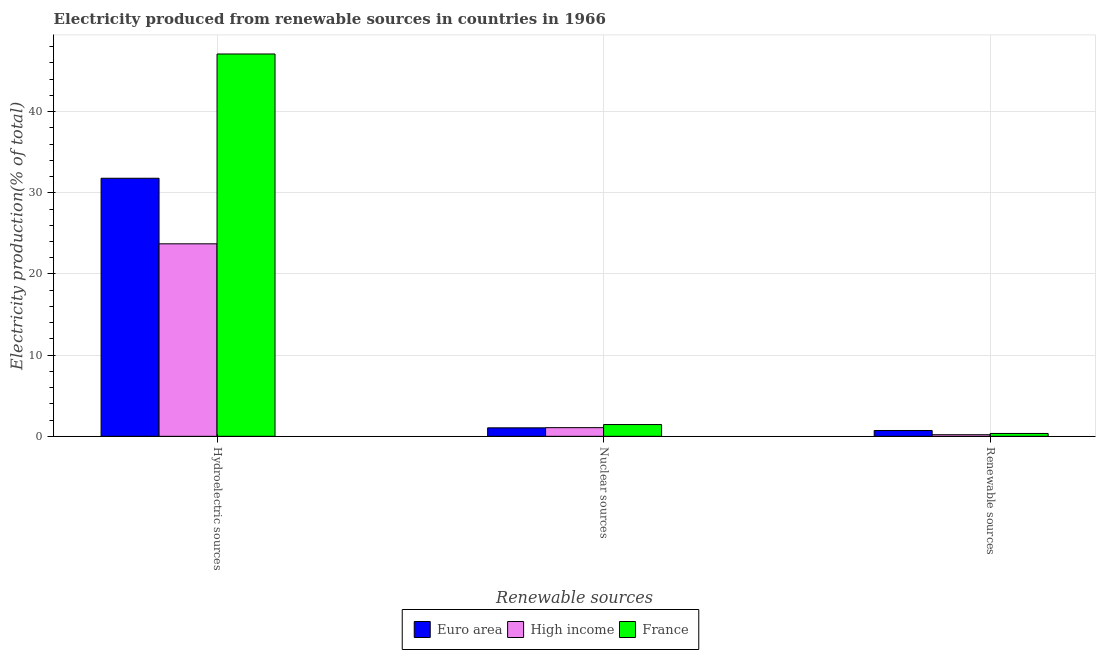How many different coloured bars are there?
Give a very brief answer. 3. How many groups of bars are there?
Your answer should be very brief. 3. Are the number of bars per tick equal to the number of legend labels?
Ensure brevity in your answer.  Yes. Are the number of bars on each tick of the X-axis equal?
Your response must be concise. Yes. How many bars are there on the 2nd tick from the left?
Provide a succinct answer. 3. How many bars are there on the 1st tick from the right?
Your response must be concise. 3. What is the label of the 2nd group of bars from the left?
Your answer should be compact. Nuclear sources. What is the percentage of electricity produced by nuclear sources in High income?
Give a very brief answer. 1.07. Across all countries, what is the maximum percentage of electricity produced by renewable sources?
Your response must be concise. 0.72. Across all countries, what is the minimum percentage of electricity produced by hydroelectric sources?
Provide a succinct answer. 23.72. In which country was the percentage of electricity produced by nuclear sources minimum?
Keep it short and to the point. Euro area. What is the total percentage of electricity produced by hydroelectric sources in the graph?
Your answer should be very brief. 102.61. What is the difference between the percentage of electricity produced by renewable sources in France and that in Euro area?
Your response must be concise. -0.37. What is the difference between the percentage of electricity produced by nuclear sources in France and the percentage of electricity produced by renewable sources in High income?
Provide a short and direct response. 1.25. What is the average percentage of electricity produced by nuclear sources per country?
Offer a terse response. 1.19. What is the difference between the percentage of electricity produced by hydroelectric sources and percentage of electricity produced by renewable sources in High income?
Provide a short and direct response. 23.52. What is the ratio of the percentage of electricity produced by hydroelectric sources in High income to that in Euro area?
Give a very brief answer. 0.75. What is the difference between the highest and the second highest percentage of electricity produced by nuclear sources?
Give a very brief answer. 0.38. What is the difference between the highest and the lowest percentage of electricity produced by nuclear sources?
Provide a short and direct response. 0.4. What does the 3rd bar from the left in Renewable sources represents?
Offer a very short reply. France. How many bars are there?
Ensure brevity in your answer.  9. Are all the bars in the graph horizontal?
Offer a very short reply. No. How many countries are there in the graph?
Your answer should be very brief. 3. Where does the legend appear in the graph?
Ensure brevity in your answer.  Bottom center. What is the title of the graph?
Offer a very short reply. Electricity produced from renewable sources in countries in 1966. Does "Faeroe Islands" appear as one of the legend labels in the graph?
Ensure brevity in your answer.  No. What is the label or title of the X-axis?
Your response must be concise. Renewable sources. What is the label or title of the Y-axis?
Your response must be concise. Electricity production(% of total). What is the Electricity production(% of total) of Euro area in Hydroelectric sources?
Ensure brevity in your answer.  31.79. What is the Electricity production(% of total) in High income in Hydroelectric sources?
Your answer should be compact. 23.72. What is the Electricity production(% of total) in France in Hydroelectric sources?
Your response must be concise. 47.1. What is the Electricity production(% of total) in Euro area in Nuclear sources?
Provide a short and direct response. 1.04. What is the Electricity production(% of total) in High income in Nuclear sources?
Give a very brief answer. 1.07. What is the Electricity production(% of total) of France in Nuclear sources?
Provide a short and direct response. 1.45. What is the Electricity production(% of total) in Euro area in Renewable sources?
Ensure brevity in your answer.  0.72. What is the Electricity production(% of total) of High income in Renewable sources?
Your answer should be very brief. 0.2. What is the Electricity production(% of total) in France in Renewable sources?
Ensure brevity in your answer.  0.35. Across all Renewable sources, what is the maximum Electricity production(% of total) of Euro area?
Offer a terse response. 31.79. Across all Renewable sources, what is the maximum Electricity production(% of total) in High income?
Offer a very short reply. 23.72. Across all Renewable sources, what is the maximum Electricity production(% of total) of France?
Offer a very short reply. 47.1. Across all Renewable sources, what is the minimum Electricity production(% of total) in Euro area?
Give a very brief answer. 0.72. Across all Renewable sources, what is the minimum Electricity production(% of total) of High income?
Offer a terse response. 0.2. Across all Renewable sources, what is the minimum Electricity production(% of total) of France?
Your answer should be very brief. 0.35. What is the total Electricity production(% of total) of Euro area in the graph?
Offer a very short reply. 33.56. What is the total Electricity production(% of total) of High income in the graph?
Provide a succinct answer. 24.98. What is the total Electricity production(% of total) of France in the graph?
Keep it short and to the point. 48.9. What is the difference between the Electricity production(% of total) in Euro area in Hydroelectric sources and that in Nuclear sources?
Offer a very short reply. 30.75. What is the difference between the Electricity production(% of total) of High income in Hydroelectric sources and that in Nuclear sources?
Offer a terse response. 22.65. What is the difference between the Electricity production(% of total) in France in Hydroelectric sources and that in Nuclear sources?
Provide a short and direct response. 45.65. What is the difference between the Electricity production(% of total) in Euro area in Hydroelectric sources and that in Renewable sources?
Your answer should be compact. 31.08. What is the difference between the Electricity production(% of total) in High income in Hydroelectric sources and that in Renewable sources?
Offer a very short reply. 23.52. What is the difference between the Electricity production(% of total) in France in Hydroelectric sources and that in Renewable sources?
Offer a very short reply. 46.75. What is the difference between the Electricity production(% of total) of Euro area in Nuclear sources and that in Renewable sources?
Offer a very short reply. 0.33. What is the difference between the Electricity production(% of total) in High income in Nuclear sources and that in Renewable sources?
Your answer should be compact. 0.87. What is the difference between the Electricity production(% of total) in France in Nuclear sources and that in Renewable sources?
Provide a short and direct response. 1.1. What is the difference between the Electricity production(% of total) in Euro area in Hydroelectric sources and the Electricity production(% of total) in High income in Nuclear sources?
Your answer should be very brief. 30.73. What is the difference between the Electricity production(% of total) in Euro area in Hydroelectric sources and the Electricity production(% of total) in France in Nuclear sources?
Your response must be concise. 30.34. What is the difference between the Electricity production(% of total) of High income in Hydroelectric sources and the Electricity production(% of total) of France in Nuclear sources?
Your answer should be very brief. 22.27. What is the difference between the Electricity production(% of total) of Euro area in Hydroelectric sources and the Electricity production(% of total) of High income in Renewable sources?
Your response must be concise. 31.6. What is the difference between the Electricity production(% of total) in Euro area in Hydroelectric sources and the Electricity production(% of total) in France in Renewable sources?
Provide a succinct answer. 31.44. What is the difference between the Electricity production(% of total) in High income in Hydroelectric sources and the Electricity production(% of total) in France in Renewable sources?
Your answer should be compact. 23.36. What is the difference between the Electricity production(% of total) in Euro area in Nuclear sources and the Electricity production(% of total) in High income in Renewable sources?
Your answer should be compact. 0.85. What is the difference between the Electricity production(% of total) of Euro area in Nuclear sources and the Electricity production(% of total) of France in Renewable sources?
Your response must be concise. 0.69. What is the difference between the Electricity production(% of total) of High income in Nuclear sources and the Electricity production(% of total) of France in Renewable sources?
Ensure brevity in your answer.  0.72. What is the average Electricity production(% of total) in Euro area per Renewable sources?
Give a very brief answer. 11.19. What is the average Electricity production(% of total) in High income per Renewable sources?
Your response must be concise. 8.33. What is the average Electricity production(% of total) of France per Renewable sources?
Your answer should be compact. 16.3. What is the difference between the Electricity production(% of total) in Euro area and Electricity production(% of total) in High income in Hydroelectric sources?
Offer a terse response. 8.08. What is the difference between the Electricity production(% of total) of Euro area and Electricity production(% of total) of France in Hydroelectric sources?
Your answer should be compact. -15.31. What is the difference between the Electricity production(% of total) of High income and Electricity production(% of total) of France in Hydroelectric sources?
Offer a terse response. -23.39. What is the difference between the Electricity production(% of total) in Euro area and Electricity production(% of total) in High income in Nuclear sources?
Your answer should be compact. -0.02. What is the difference between the Electricity production(% of total) of Euro area and Electricity production(% of total) of France in Nuclear sources?
Your answer should be very brief. -0.4. What is the difference between the Electricity production(% of total) of High income and Electricity production(% of total) of France in Nuclear sources?
Your response must be concise. -0.38. What is the difference between the Electricity production(% of total) in Euro area and Electricity production(% of total) in High income in Renewable sources?
Keep it short and to the point. 0.52. What is the difference between the Electricity production(% of total) of Euro area and Electricity production(% of total) of France in Renewable sources?
Your answer should be compact. 0.37. What is the difference between the Electricity production(% of total) of High income and Electricity production(% of total) of France in Renewable sources?
Your answer should be very brief. -0.16. What is the ratio of the Electricity production(% of total) in Euro area in Hydroelectric sources to that in Nuclear sources?
Your answer should be very brief. 30.43. What is the ratio of the Electricity production(% of total) of High income in Hydroelectric sources to that in Nuclear sources?
Give a very brief answer. 22.22. What is the ratio of the Electricity production(% of total) in France in Hydroelectric sources to that in Nuclear sources?
Offer a terse response. 32.5. What is the ratio of the Electricity production(% of total) in Euro area in Hydroelectric sources to that in Renewable sources?
Offer a very short reply. 44.32. What is the ratio of the Electricity production(% of total) in High income in Hydroelectric sources to that in Renewable sources?
Offer a very short reply. 120.9. What is the ratio of the Electricity production(% of total) of France in Hydroelectric sources to that in Renewable sources?
Offer a terse response. 133.84. What is the ratio of the Electricity production(% of total) of Euro area in Nuclear sources to that in Renewable sources?
Make the answer very short. 1.46. What is the ratio of the Electricity production(% of total) in High income in Nuclear sources to that in Renewable sources?
Your answer should be very brief. 5.44. What is the ratio of the Electricity production(% of total) in France in Nuclear sources to that in Renewable sources?
Your answer should be very brief. 4.12. What is the difference between the highest and the second highest Electricity production(% of total) in Euro area?
Your answer should be compact. 30.75. What is the difference between the highest and the second highest Electricity production(% of total) in High income?
Your answer should be very brief. 22.65. What is the difference between the highest and the second highest Electricity production(% of total) of France?
Your response must be concise. 45.65. What is the difference between the highest and the lowest Electricity production(% of total) in Euro area?
Your response must be concise. 31.08. What is the difference between the highest and the lowest Electricity production(% of total) of High income?
Give a very brief answer. 23.52. What is the difference between the highest and the lowest Electricity production(% of total) of France?
Make the answer very short. 46.75. 